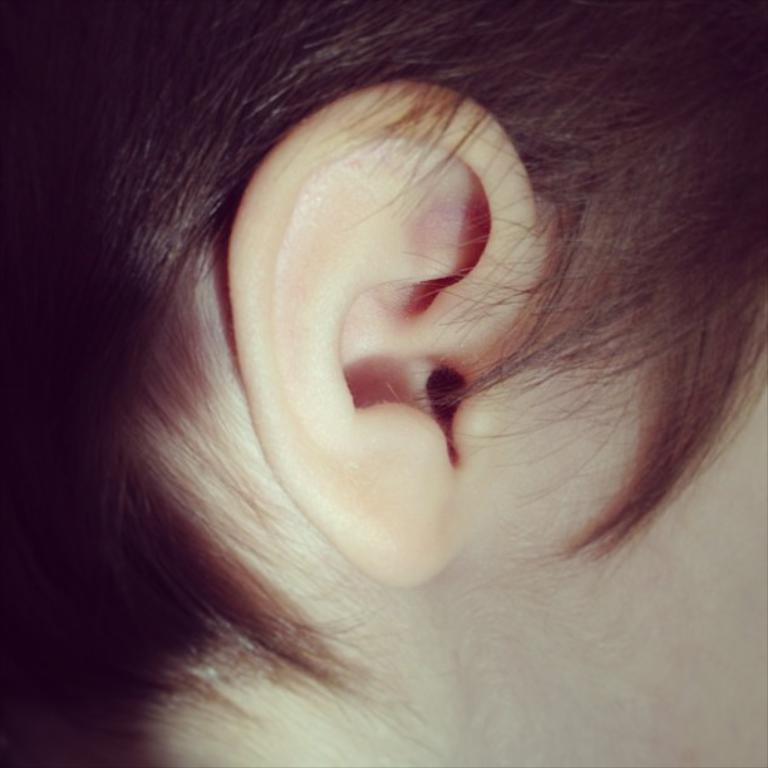What type of body part can be seen in the image? There is an ear visible in the image. What else can be seen in the image besides the ear? Hair is visible in the image. What type of vase is visible in the image? There is no vase present in the image; it only features hair and an ear. 